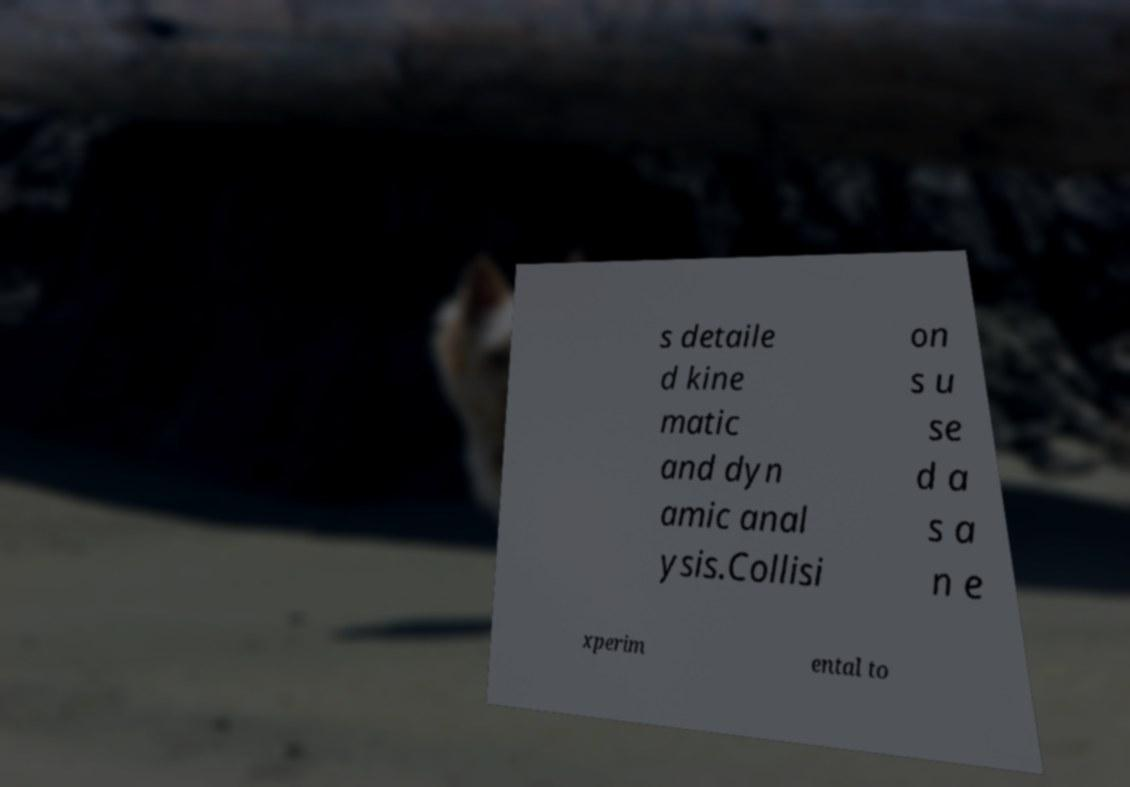I need the written content from this picture converted into text. Can you do that? s detaile d kine matic and dyn amic anal ysis.Collisi on s u se d a s a n e xperim ental to 